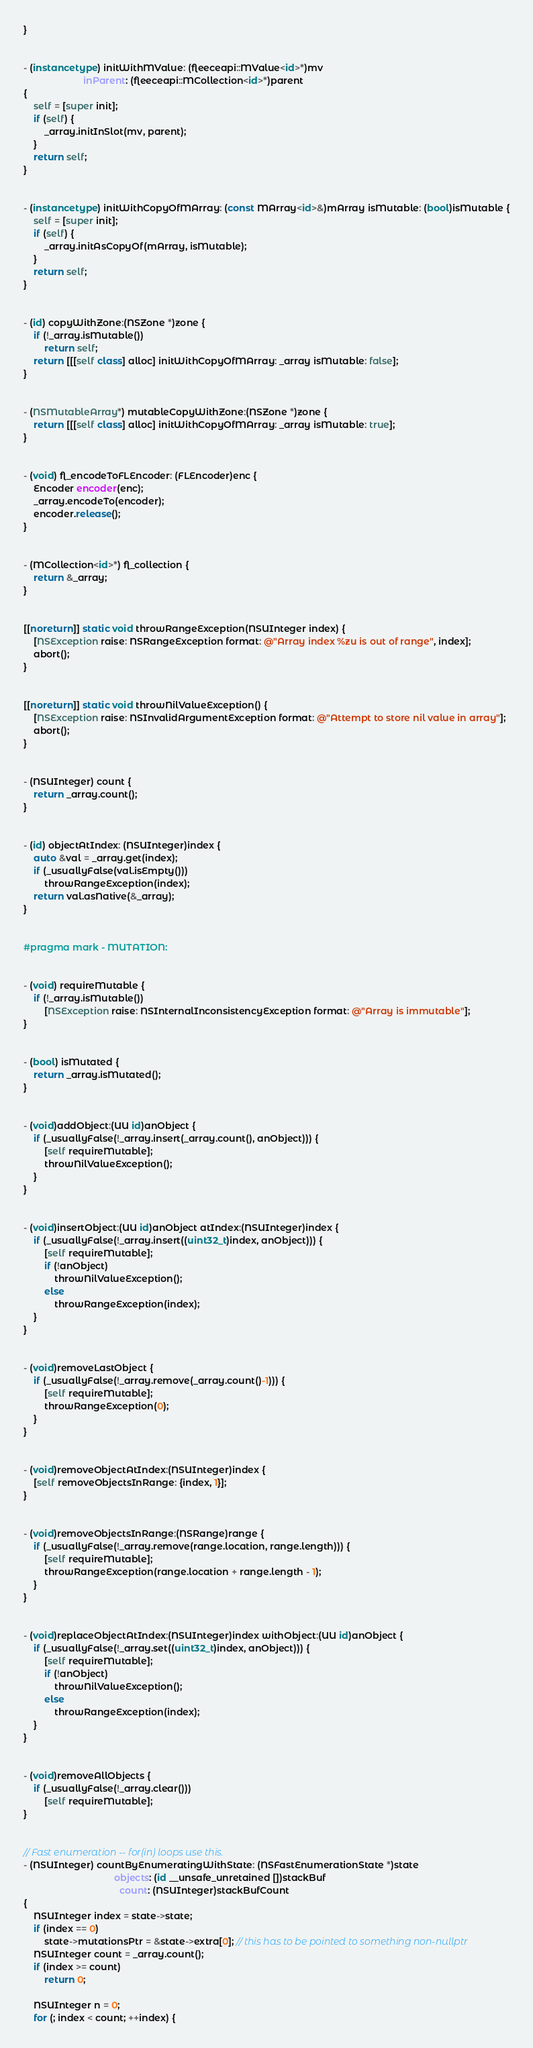<code> <loc_0><loc_0><loc_500><loc_500><_ObjectiveC_>}


- (instancetype) initWithMValue: (fleeceapi::MValue<id>*)mv
                       inParent: (fleeceapi::MCollection<id>*)parent
{
    self = [super init];
    if (self) {
        _array.initInSlot(mv, parent);
    }
    return self;
}


- (instancetype) initWithCopyOfMArray: (const MArray<id>&)mArray isMutable: (bool)isMutable {
    self = [super init];
    if (self) {
        _array.initAsCopyOf(mArray, isMutable);
    }
    return self;
}


- (id) copyWithZone:(NSZone *)zone {
    if (!_array.isMutable())
        return self;
    return [[[self class] alloc] initWithCopyOfMArray: _array isMutable: false];
}


- (NSMutableArray*) mutableCopyWithZone:(NSZone *)zone {
    return [[[self class] alloc] initWithCopyOfMArray: _array isMutable: true];
}


- (void) fl_encodeToFLEncoder: (FLEncoder)enc {
    Encoder encoder(enc);
    _array.encodeTo(encoder);
    encoder.release();
}


- (MCollection<id>*) fl_collection {
    return &_array;
}


[[noreturn]] static void throwRangeException(NSUInteger index) {
    [NSException raise: NSRangeException format: @"Array index %zu is out of range", index];
    abort();
}


[[noreturn]] static void throwNilValueException() {
    [NSException raise: NSInvalidArgumentException format: @"Attempt to store nil value in array"];
    abort();
}


- (NSUInteger) count {
    return _array.count();
}


- (id) objectAtIndex: (NSUInteger)index {
    auto &val = _array.get(index);
    if (_usuallyFalse(val.isEmpty()))
        throwRangeException(index);
    return val.asNative(&_array);
}


#pragma mark - MUTATION:


- (void) requireMutable {
    if (!_array.isMutable())
        [NSException raise: NSInternalInconsistencyException format: @"Array is immutable"];
}


- (bool) isMutated {
    return _array.isMutated();
}


- (void)addObject:(UU id)anObject {
    if (_usuallyFalse(!_array.insert(_array.count(), anObject))) {
        [self requireMutable];
        throwNilValueException();
    }
}


- (void)insertObject:(UU id)anObject atIndex:(NSUInteger)index {
    if (_usuallyFalse(!_array.insert((uint32_t)index, anObject))) {
        [self requireMutable];
        if (!anObject)
            throwNilValueException();
        else
            throwRangeException(index);
    }
}


- (void)removeLastObject {
    if (_usuallyFalse(!_array.remove(_array.count()-1))) {
        [self requireMutable];
        throwRangeException(0);
    }
}


- (void)removeObjectAtIndex:(NSUInteger)index {
    [self removeObjectsInRange: {index, 1}];
}


- (void)removeObjectsInRange:(NSRange)range {
    if (_usuallyFalse(!_array.remove(range.location, range.length))) {
        [self requireMutable];
        throwRangeException(range.location + range.length - 1);
    }
}


- (void)replaceObjectAtIndex:(NSUInteger)index withObject:(UU id)anObject {
    if (_usuallyFalse(!_array.set((uint32_t)index, anObject))) {
        [self requireMutable];
        if (!anObject)
            throwNilValueException();
        else
            throwRangeException(index);
    }
}


- (void)removeAllObjects {
    if (_usuallyFalse(!_array.clear()))
        [self requireMutable];
}


// Fast enumeration -- for(in) loops use this.
- (NSUInteger) countByEnumeratingWithState: (NSFastEnumerationState *)state
                                   objects: (id __unsafe_unretained [])stackBuf
                                     count: (NSUInteger)stackBufCount
{
    NSUInteger index = state->state;
    if (index == 0)
        state->mutationsPtr = &state->extra[0]; // this has to be pointed to something non-nullptr
    NSUInteger count = _array.count();
    if (index >= count)
        return 0;

    NSUInteger n = 0;
    for (; index < count; ++index) {</code> 